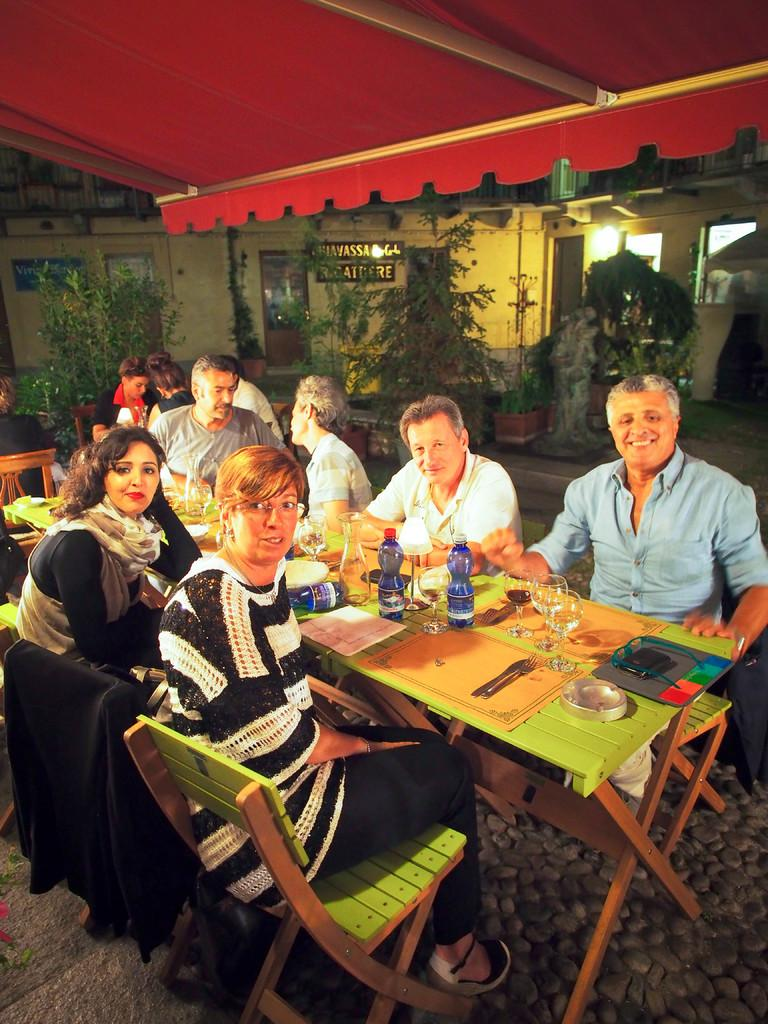What is the main piece of furniture in the image? There is a table in the image. What are the people in the image doing? People are sitting around the table. What utensils can be seen on the table? There are spoons on the table. What else is on the table besides spoons? There are glasses and bottles on the table. What can be seen in the background of the image? There are plants and a building visible in the background. What type of distribution system is being used by the achiever in the image? There is no achiever present in the image, and therefore no distribution system can be observed. 